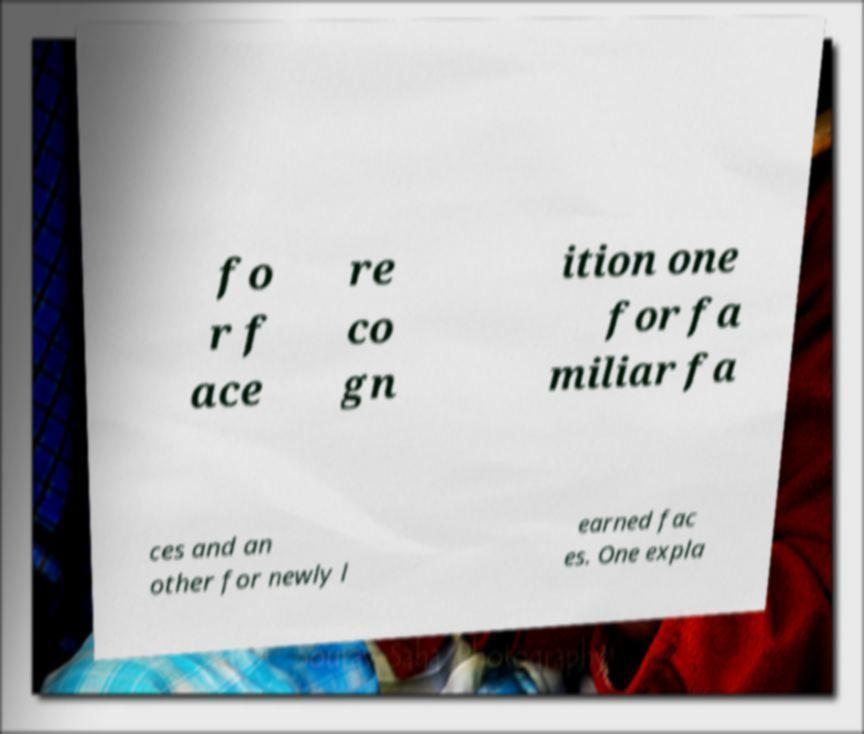Please read and relay the text visible in this image. What does it say? fo r f ace re co gn ition one for fa miliar fa ces and an other for newly l earned fac es. One expla 